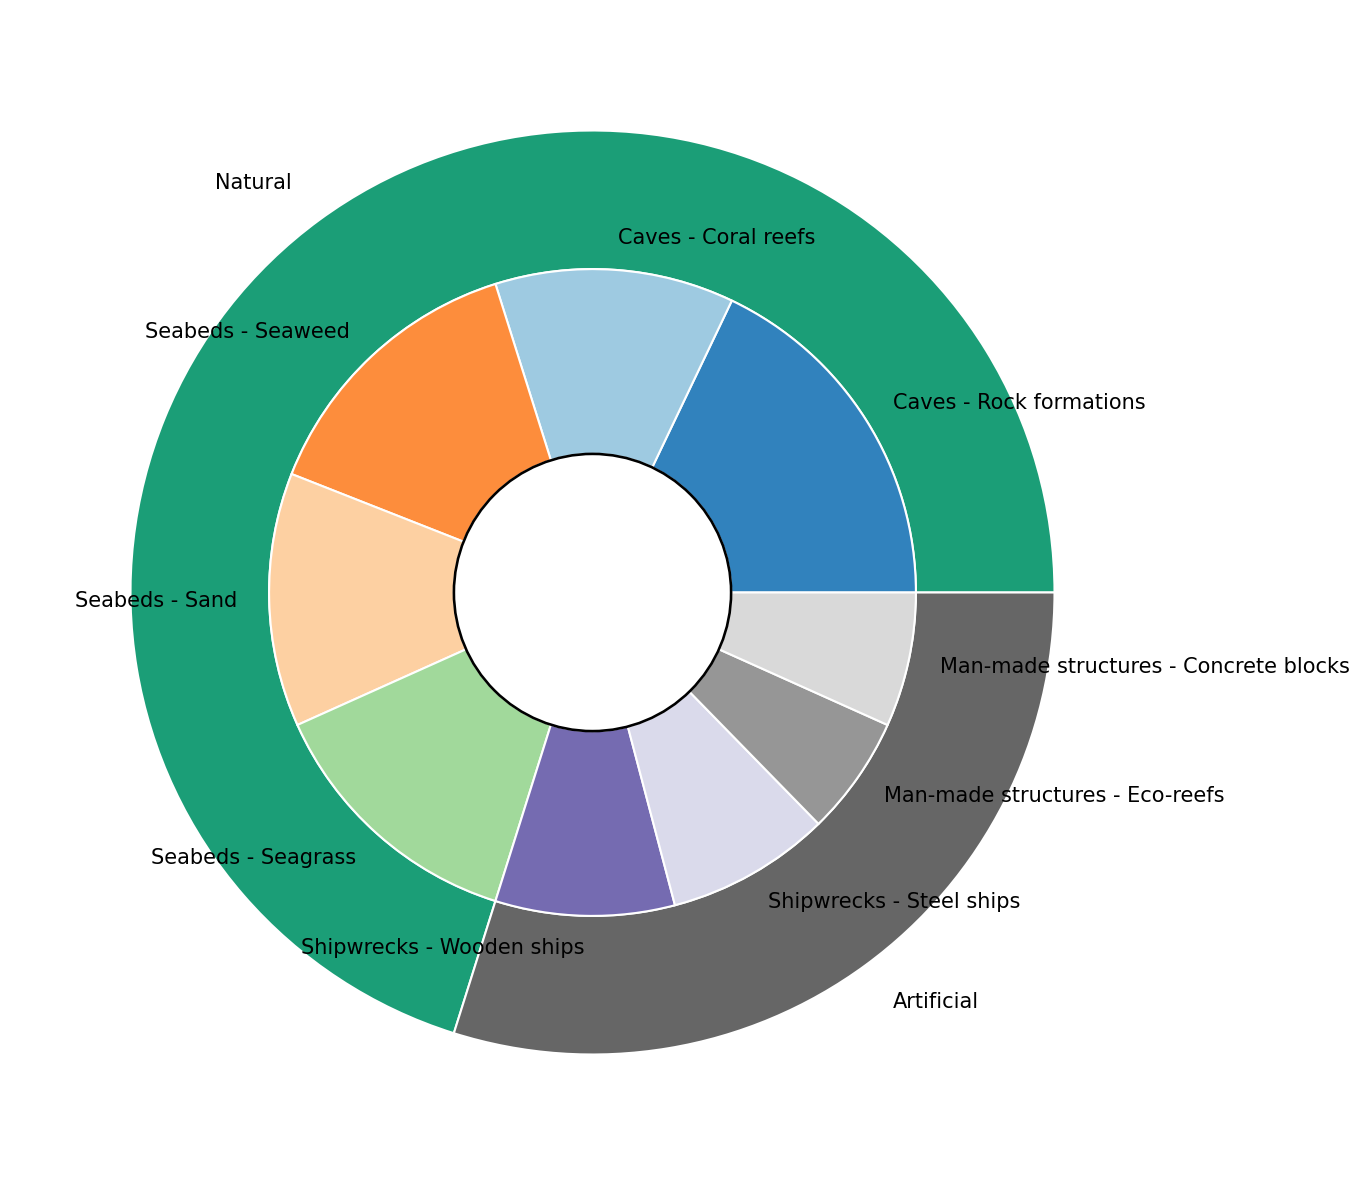What is the total number of natural hideaways in the figure? Sum the counts of all subcategories under "Natural": 120 (Rock formations) + 80 (Coral reefs) + 95 (Seaweed) + 85 (Sand) + 90 (Seagrass) = 470
Answer: 470 Which type of hideaway has the highest number—the natural or the artificial? Compare the total counts: Natural has 470, while Artificial has 60 (Wooden ships) + 55 (Steel ships) + 40 (Eco-reefs) + 45 (Concrete blocks) = 200. Natural is higher.
Answer: Natural How many more natural hideaways' seabeds are there compared to artificial hideaways' man-made structures? Calculate the number of seabeds: 95 (Seaweed) + 85 (Sand) + 90 (Seagrass) = 270. For man-made structures: 40 (Eco-reefs) + 45 (Concrete blocks) = 85. Difference = 270 - 85 = 185
Answer: 185 Which subcategory has the least count in artificial hideaways, and what is its count? Look at the artificial subcategories: Wooden ships (60), Steel ships (55), Eco-reefs (40), Concrete blocks (45). Eco-reefs have the least with 40.
Answer: Eco-reefs, 40 Are there more natural caves or artificial shipwrecks? Calculate for natural caves: 120 (Rock formations) + 80 (Coral reefs) = 200. For artificial shipwrecks: 60 (Wooden ships) + 55 (Steel ships) = 115. Natural caves are more.
Answer: Natural caves What is the proportion of coral reefs within the natural category? Total natural count is 470. Coral reefs are 80. Proportion = 80 / 470 * 100 ≈ 17.02%
Answer: 17.02% Which subcategory has a closer count to seagrass in natural seabeds? Seagrass count is 90. Compare with seaweed (95) and sand (85). Sand is closer.
Answer: Sand If we were to combine all man-made structures and shipwrecks, would this new category have more hideaways than natural seabeds? Combine artificial subcategories: 85 (man-made structures) + 115 (shipwrecks) = 200. Natural seabeds = 270. Natural seabeds are still more.
Answer: No What is the ratio of wooden ships to steel ships in artificial hideaways? Wooden ships = 60, Steel ships = 55. Ratio = 60 : 55 or 12 : 11.
Answer: 12 : 11 Which category has more diverse subcategories, and by how many? Natural: Caves (2), Seabeds (3) total 5. Artificial: Shipwrecks (2), Man-made structures (2) total 4. Natural has 1 more subcategory.
Answer: Natural, 1 